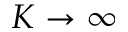<formula> <loc_0><loc_0><loc_500><loc_500>K \rightarrow \infty</formula> 